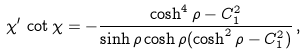Convert formula to latex. <formula><loc_0><loc_0><loc_500><loc_500>\chi ^ { \prime } \, \cot \chi = - \frac { \cosh ^ { 4 } \rho - C _ { 1 } ^ { 2 } } { \sinh \rho \cosh \rho ( \cosh ^ { 2 } \rho - C _ { 1 } ^ { 2 } ) } \, ,</formula> 